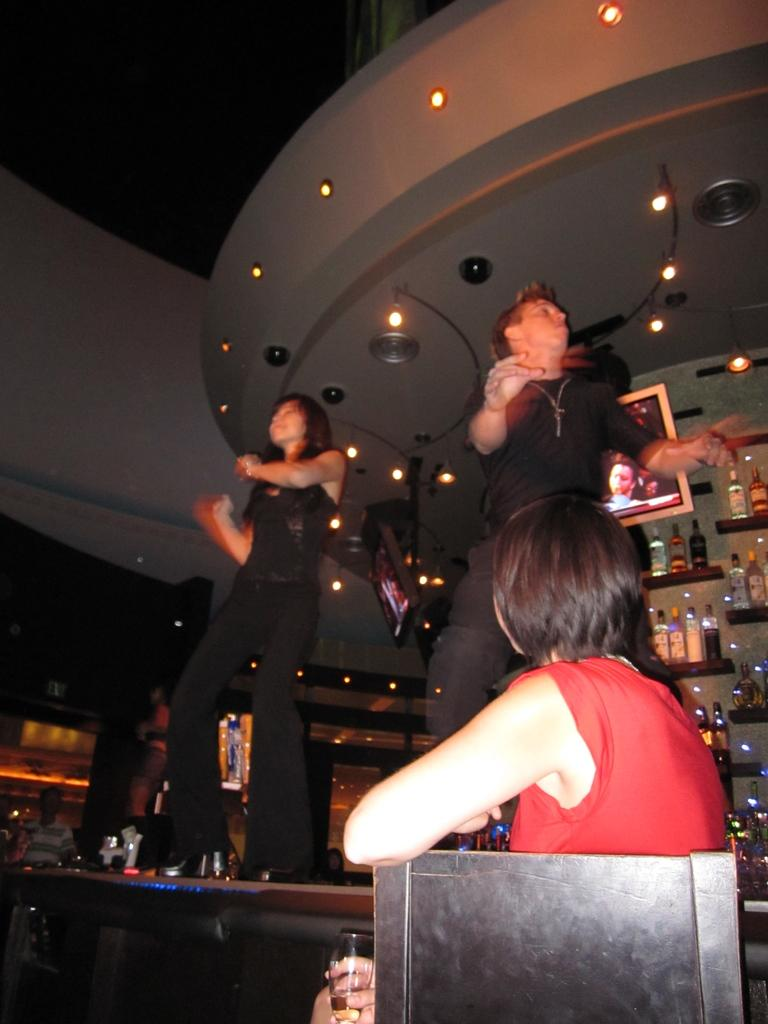How many people are in the image? There are two people standing in the image. What are the people wearing? Both people are wearing black dresses. What is the position of one of the people in the image? One person is sitting on a chair. What is the sitting person holding? The sitting person is holding a glass. What can be seen in the background of the image? There is a screen visible in the image, and there are lights as well. Can you see a kitten playing with a grape on the wall in the image? No, there is no kitten or grape on the wall in the image. 